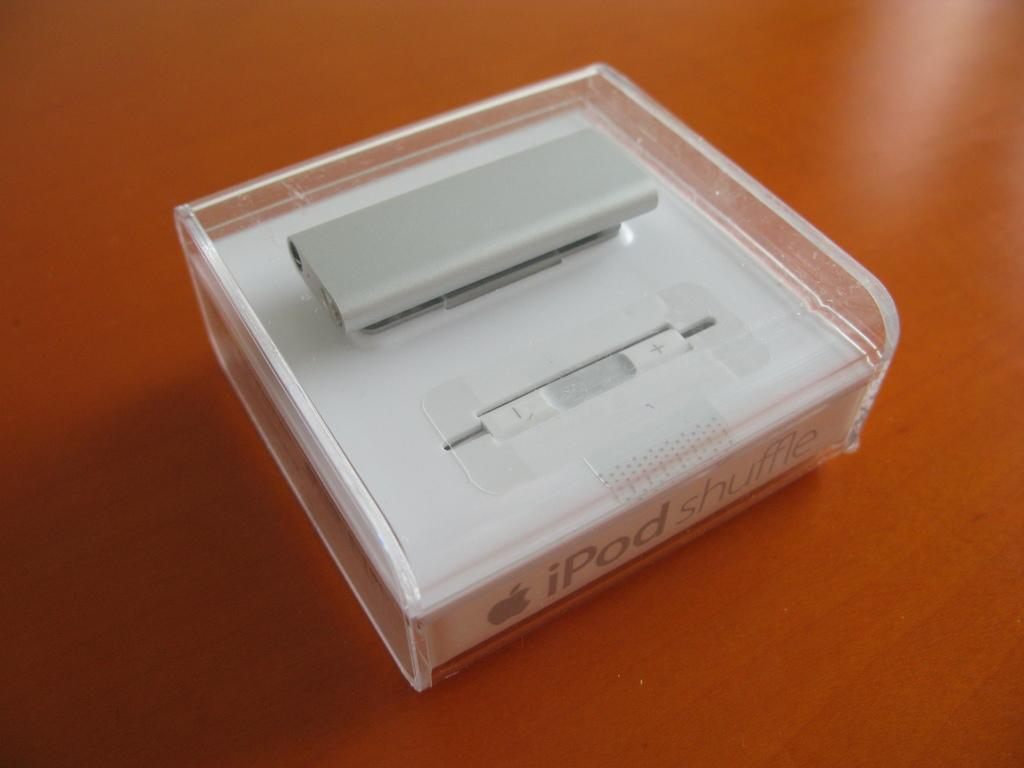<image>
Summarize the visual content of the image. A white iPod shuffle sealed in store packaging with sensor. 